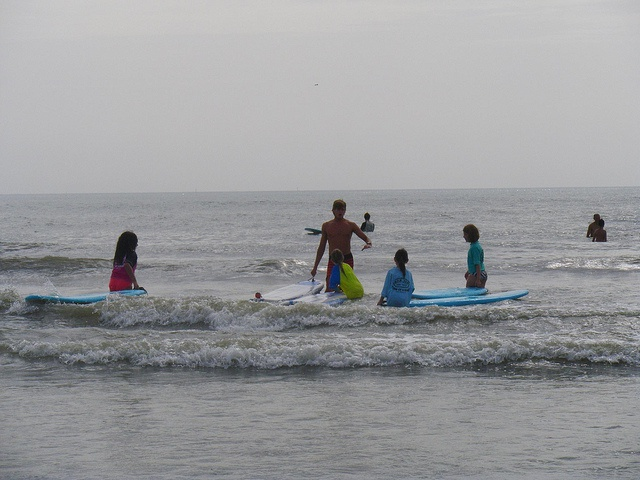Describe the objects in this image and their specific colors. I can see people in lightgray, black, maroon, gray, and darkgray tones, people in lightgray, black, maroon, darkgray, and gray tones, people in lightgray, blue, black, and darkblue tones, surfboard in lightgray, blue, darkgray, gray, and lightblue tones, and people in lightgray, black, teal, and darkblue tones in this image. 